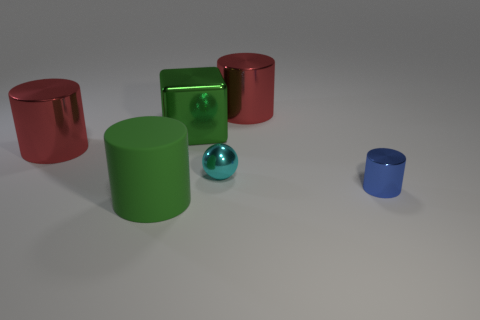What is the material of the big cylinder that is the same color as the large cube?
Your answer should be compact. Rubber. What number of tiny objects are left of the red shiny cylinder that is in front of the big red thing to the right of the block?
Provide a succinct answer. 0. What number of tiny cylinders are in front of the big green metal cube?
Give a very brief answer. 1. What number of other small balls are made of the same material as the cyan ball?
Your answer should be compact. 0. What is the color of the block that is made of the same material as the cyan object?
Make the answer very short. Green. What material is the large object that is left of the large green rubber cylinder in front of the red shiny thing that is behind the big cube made of?
Provide a short and direct response. Metal. There is a cylinder that is in front of the blue metallic object; is it the same size as the large metallic cube?
Keep it short and to the point. Yes. How many tiny objects are yellow matte things or green rubber cylinders?
Provide a short and direct response. 0. Are there any other big cylinders of the same color as the rubber cylinder?
Your answer should be compact. No. The green metal object that is the same size as the green rubber object is what shape?
Keep it short and to the point. Cube. 